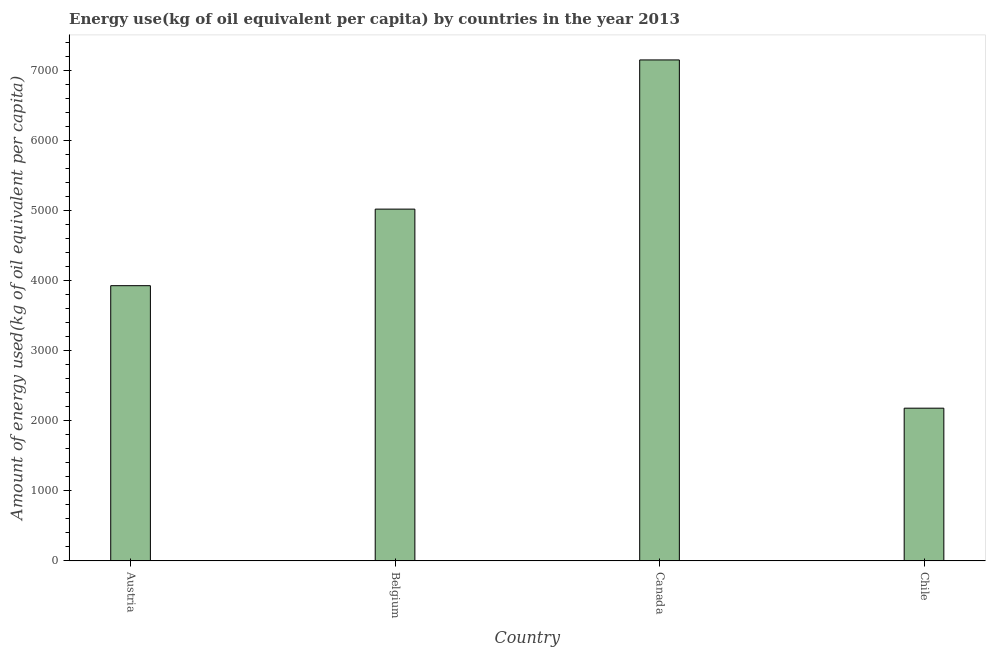Does the graph contain any zero values?
Your answer should be very brief. No. What is the title of the graph?
Your answer should be very brief. Energy use(kg of oil equivalent per capita) by countries in the year 2013. What is the label or title of the X-axis?
Offer a terse response. Country. What is the label or title of the Y-axis?
Provide a succinct answer. Amount of energy used(kg of oil equivalent per capita). What is the amount of energy used in Chile?
Ensure brevity in your answer.  2179.42. Across all countries, what is the maximum amount of energy used?
Offer a very short reply. 7149.31. Across all countries, what is the minimum amount of energy used?
Provide a short and direct response. 2179.42. What is the sum of the amount of energy used?
Make the answer very short. 1.83e+04. What is the difference between the amount of energy used in Canada and Chile?
Keep it short and to the point. 4969.89. What is the average amount of energy used per country?
Give a very brief answer. 4569.15. What is the median amount of energy used?
Provide a short and direct response. 4473.93. In how many countries, is the amount of energy used greater than 6000 kg?
Your answer should be compact. 1. What is the ratio of the amount of energy used in Belgium to that in Canada?
Ensure brevity in your answer.  0.7. Is the amount of energy used in Austria less than that in Belgium?
Your answer should be compact. Yes. Is the difference between the amount of energy used in Belgium and Canada greater than the difference between any two countries?
Give a very brief answer. No. What is the difference between the highest and the second highest amount of energy used?
Offer a terse response. 2129.04. What is the difference between the highest and the lowest amount of energy used?
Ensure brevity in your answer.  4969.89. In how many countries, is the amount of energy used greater than the average amount of energy used taken over all countries?
Your response must be concise. 2. How many bars are there?
Your answer should be very brief. 4. How many countries are there in the graph?
Your response must be concise. 4. What is the Amount of energy used(kg of oil equivalent per capita) of Austria?
Provide a succinct answer. 3927.6. What is the Amount of energy used(kg of oil equivalent per capita) of Belgium?
Give a very brief answer. 5020.27. What is the Amount of energy used(kg of oil equivalent per capita) of Canada?
Your response must be concise. 7149.31. What is the Amount of energy used(kg of oil equivalent per capita) in Chile?
Ensure brevity in your answer.  2179.42. What is the difference between the Amount of energy used(kg of oil equivalent per capita) in Austria and Belgium?
Your answer should be compact. -1092.67. What is the difference between the Amount of energy used(kg of oil equivalent per capita) in Austria and Canada?
Make the answer very short. -3221.71. What is the difference between the Amount of energy used(kg of oil equivalent per capita) in Austria and Chile?
Make the answer very short. 1748.18. What is the difference between the Amount of energy used(kg of oil equivalent per capita) in Belgium and Canada?
Offer a terse response. -2129.04. What is the difference between the Amount of energy used(kg of oil equivalent per capita) in Belgium and Chile?
Make the answer very short. 2840.85. What is the difference between the Amount of energy used(kg of oil equivalent per capita) in Canada and Chile?
Your answer should be compact. 4969.89. What is the ratio of the Amount of energy used(kg of oil equivalent per capita) in Austria to that in Belgium?
Give a very brief answer. 0.78. What is the ratio of the Amount of energy used(kg of oil equivalent per capita) in Austria to that in Canada?
Keep it short and to the point. 0.55. What is the ratio of the Amount of energy used(kg of oil equivalent per capita) in Austria to that in Chile?
Make the answer very short. 1.8. What is the ratio of the Amount of energy used(kg of oil equivalent per capita) in Belgium to that in Canada?
Keep it short and to the point. 0.7. What is the ratio of the Amount of energy used(kg of oil equivalent per capita) in Belgium to that in Chile?
Keep it short and to the point. 2.3. What is the ratio of the Amount of energy used(kg of oil equivalent per capita) in Canada to that in Chile?
Provide a succinct answer. 3.28. 